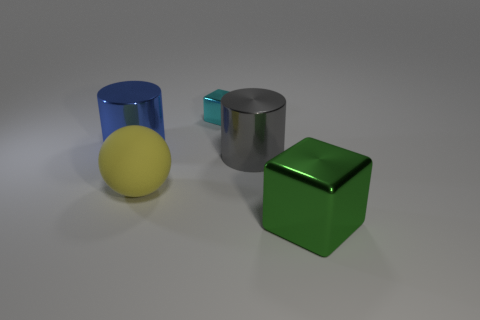Add 2 blue things. How many objects exist? 7 Subtract all balls. How many objects are left? 4 Subtract all blue cylinders. How many cylinders are left? 1 Subtract all red cylinders. Subtract all cyan cubes. How many cylinders are left? 2 Subtract all cyan balls. How many green cylinders are left? 0 Subtract all big shiny cylinders. Subtract all tiny cubes. How many objects are left? 2 Add 4 yellow objects. How many yellow objects are left? 5 Add 3 matte balls. How many matte balls exist? 4 Subtract 0 gray spheres. How many objects are left? 5 Subtract 1 cylinders. How many cylinders are left? 1 